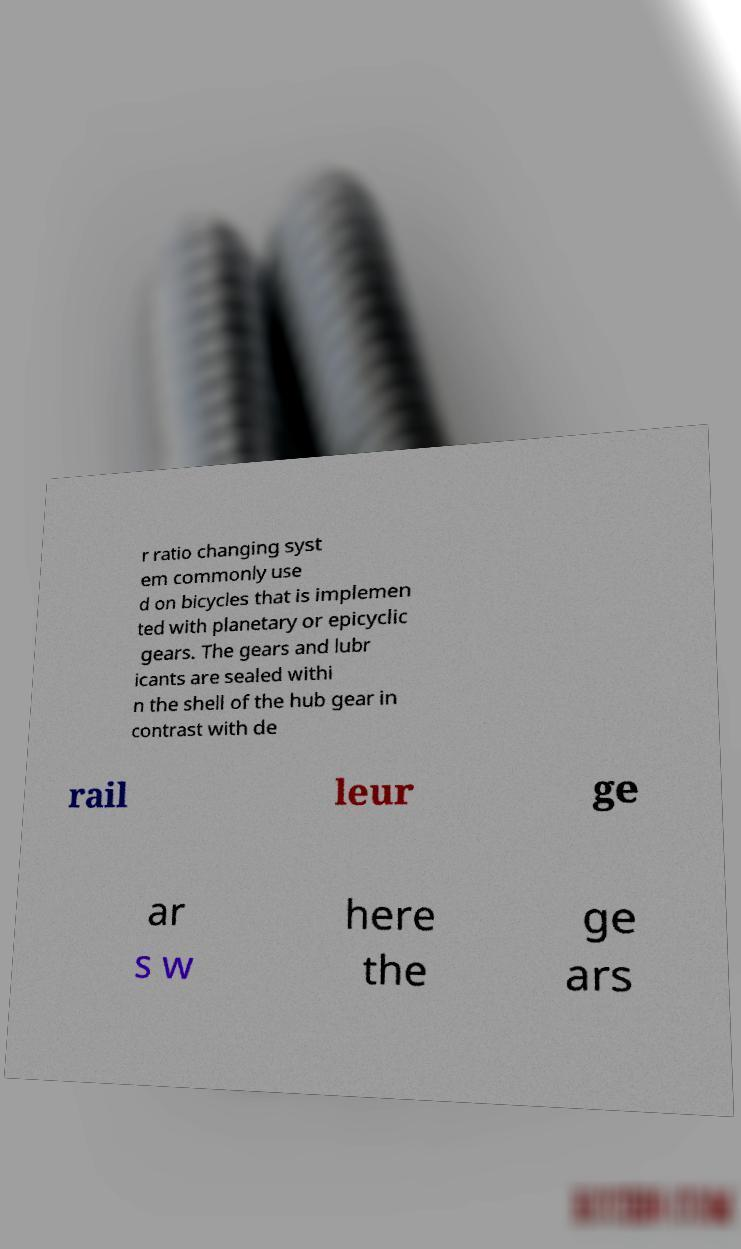Please read and relay the text visible in this image. What does it say? r ratio changing syst em commonly use d on bicycles that is implemen ted with planetary or epicyclic gears. The gears and lubr icants are sealed withi n the shell of the hub gear in contrast with de rail leur ge ar s w here the ge ars 